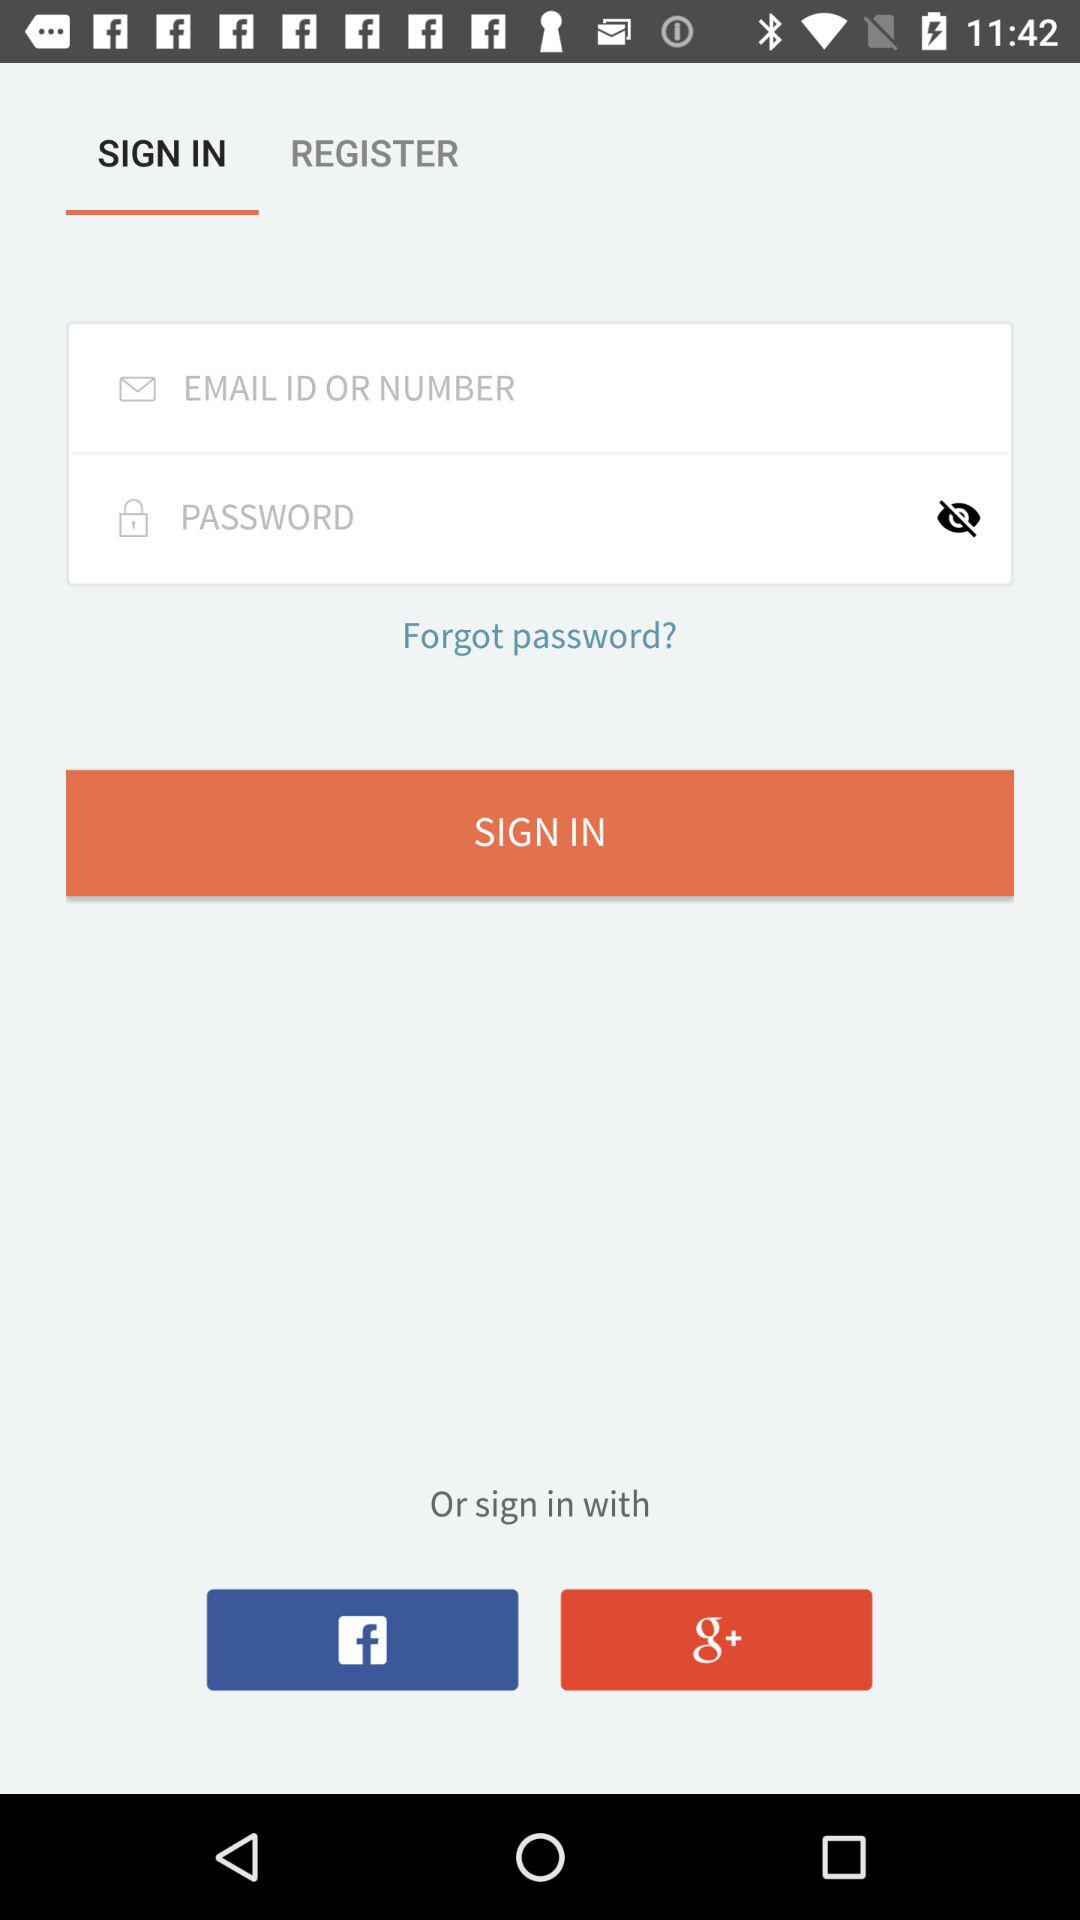Which tab has been selected? The selected tab is "SIGN IN". 